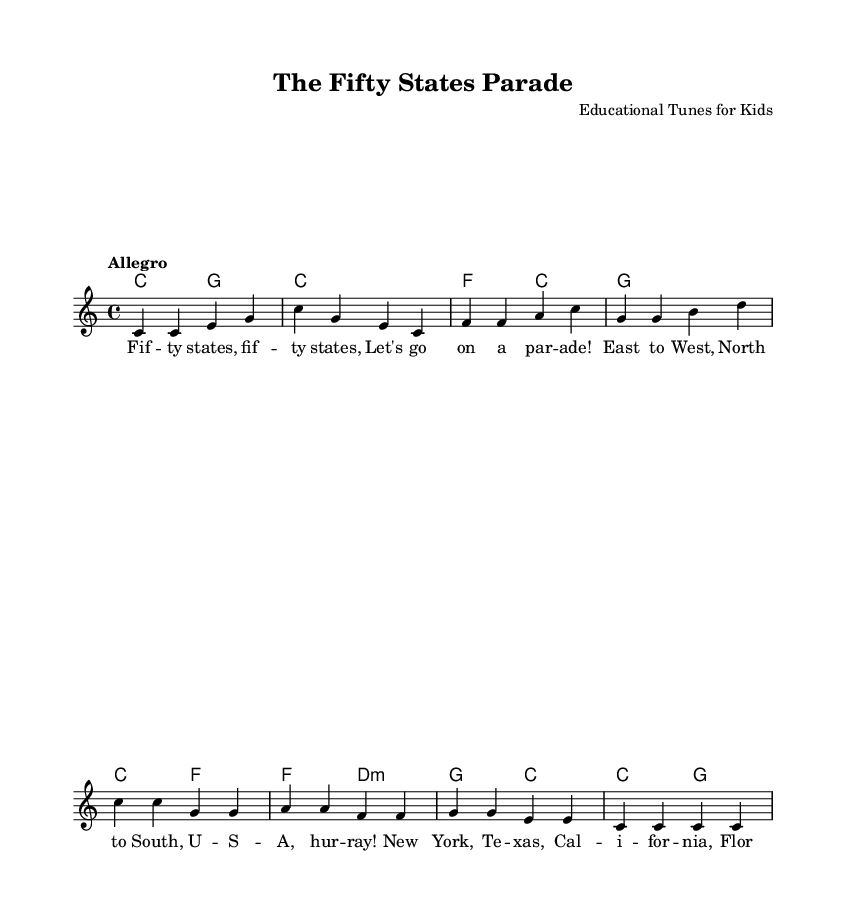What is the key signature of this music? The key signature is C major, which has no sharps or flats.
Answer: C major What is the time signature of this piece? The time signature is indicated by the notation at the beginning of the score as 4/4, meaning there are four beats per measure and a quarter note gets one beat.
Answer: 4/4 What is the tempo marking given for this song? The tempo marking is indicated in the score as "Allegro," which typically means to play at a fast tempo.
Answer: Allegro How many measures are there in this piece? Counting the measures in the melody section shows there are eight distinct measures.
Answer: Eight Which states are mentioned in the lyrics? The lyrics mention New York, Texas, California, Florida, and Illinois, all of which are stated as examples of U.S. states that children can learn about.
Answer: New York, Texas, California, Florida, Illinois What is the primary musical purpose of this song? The purpose is educational, specifically to teach children about the fifty states of the U.S. in a fun and engaging way, through melody and lyric repetition.
Answer: Educational What type of song is this classified as? This piece is classified as an educational children's song, designed to teach historical and geographical knowledge in a musical format.
Answer: Educational children's song 